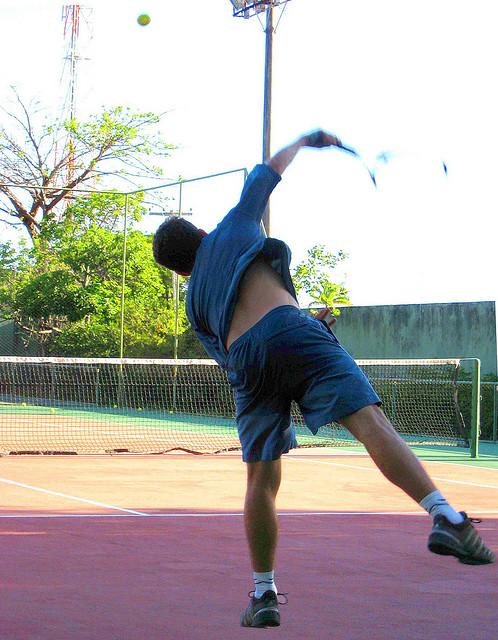What sport is this?
Concise answer only. Tennis. What game is the man playing?
Answer briefly. Tennis. Is the man wearing sweatpants?
Write a very short answer. No. 